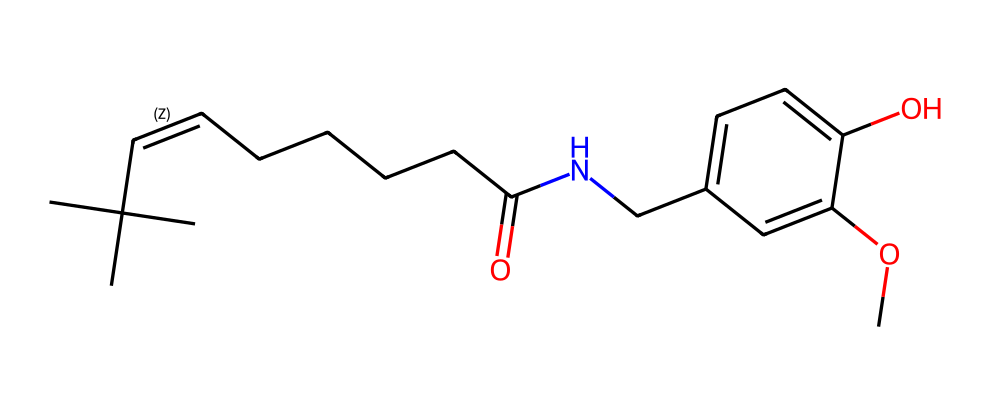What is the primary functional group in capsaicin? The structure shows an amide bond (C(=O)N), which is characterized by a carbonyl (C=O) linked to a nitrogen atom (N). This indicates the presence of an amide functional group.
Answer: amide How many carbon atoms are present in capsaicin? By analyzing the structure and counting the carbon atoms indicated by the skeletal formula, there are a total of 18 carbon atoms present in capsaicin.
Answer: 18 Does capsaicin contain any oxygen atoms? Looking at the structure, we can see two distinct functional groups containing oxygen: one in the ether (CO) and another in the phenol (OH). This confirms the presence of oxygen atoms.
Answer: yes What type of alkaloid is capsaicin classified as? Capsaicin is primarily classified as a phenolic alkaloid, evident from its aromatic ring and the presence of the nitrogen atom in its structure.
Answer: phenolic Which part of the structure contributes to the spiciness of capsaicin? The presence of the long carbon chain connected to the nitrogen atom in the amide functional group plays a crucial role in the spiciness attributed to capsaicin, as it interacts with taste receptors.
Answer: carbon chain How many hydrogen atoms are bonded to capsaicin? To determine the number of hydrogen atoms, we consider the valency of carbon and nitrogen in the structure and count the hydrogens directly implied by the structure. There are 29 hydrogen atoms attached to capsaicin.
Answer: 29 What role does the methoxy group play in capsaicin's properties? The methoxy group (CO) enhances solubility and also influences the overall biological activity, which is common for many alkaloids, thus contributing to its unique properties.
Answer: enhances solubility 